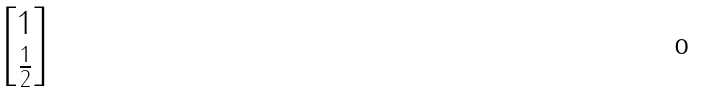Convert formula to latex. <formula><loc_0><loc_0><loc_500><loc_500>\begin{bmatrix} 1 \\ \frac { 1 } { 2 } \end{bmatrix}</formula> 